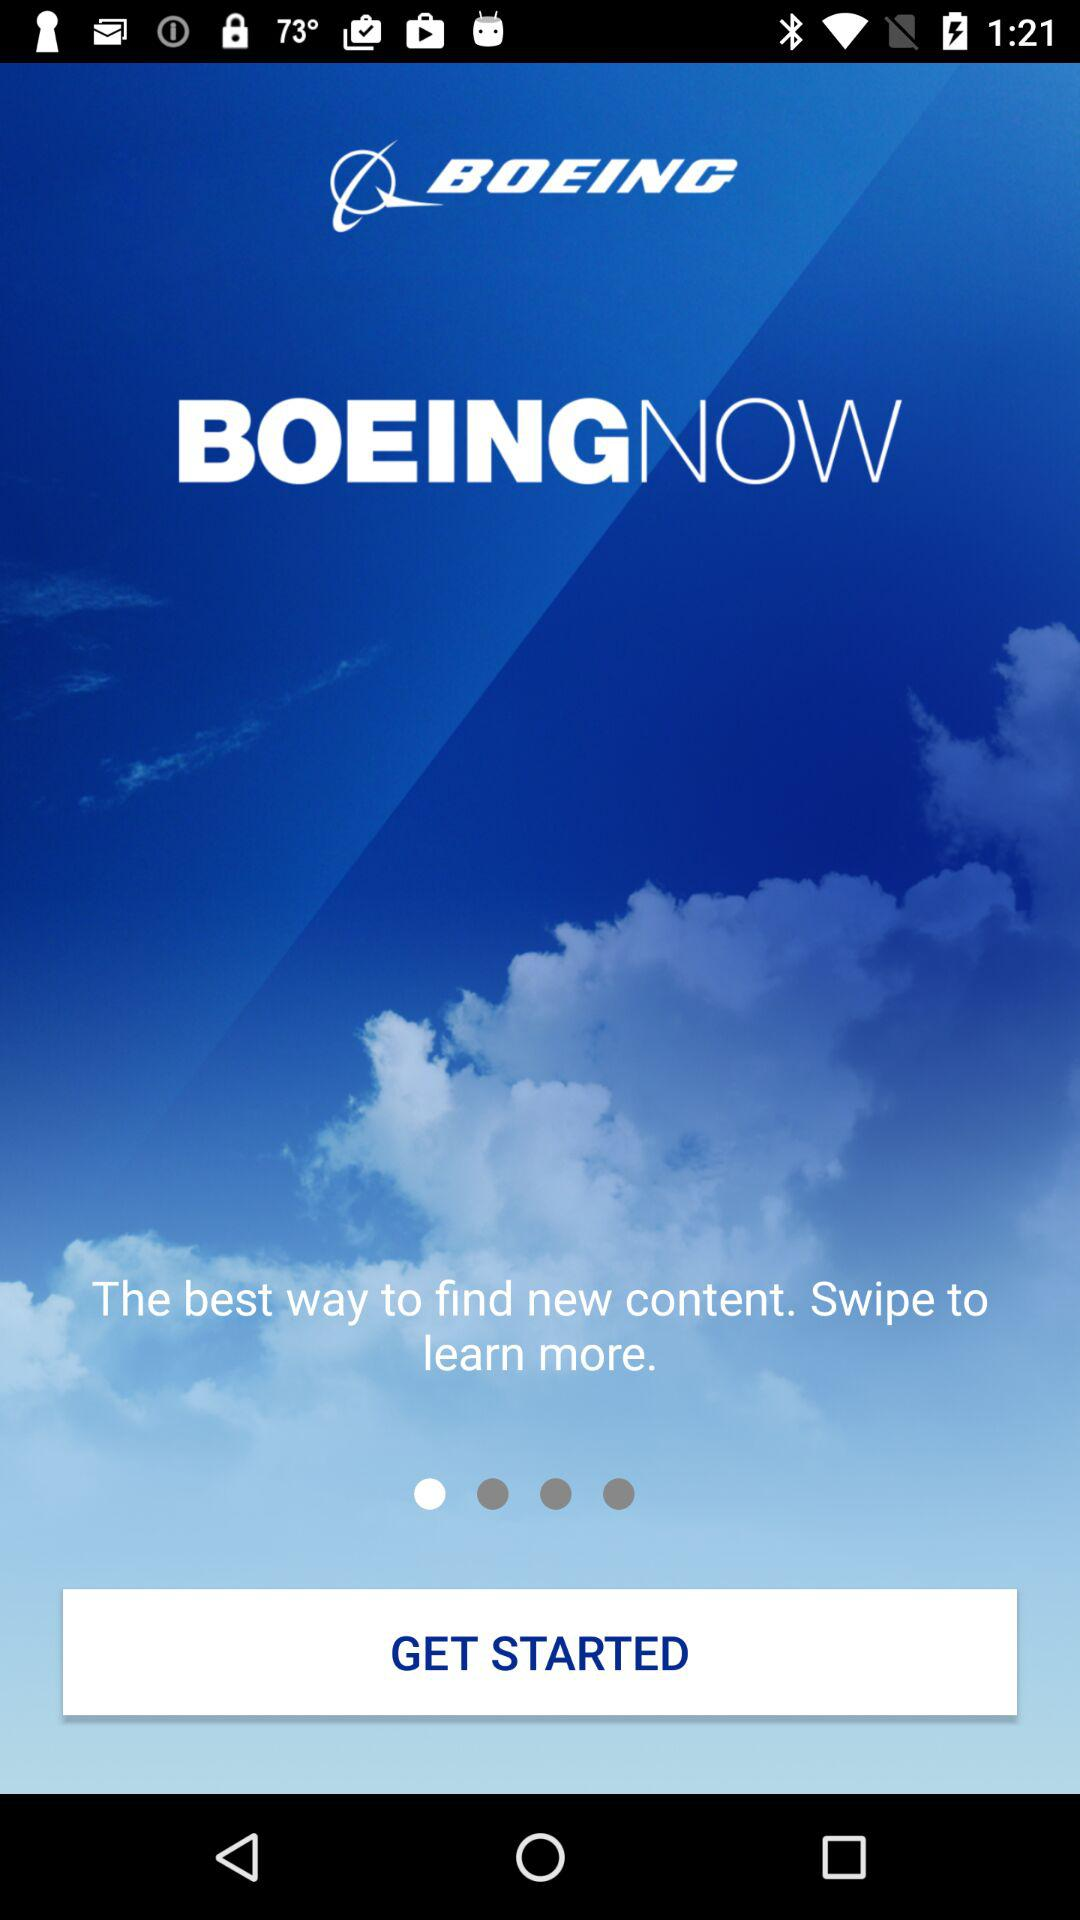What is the application name? The application name is "BOEING NOW". 